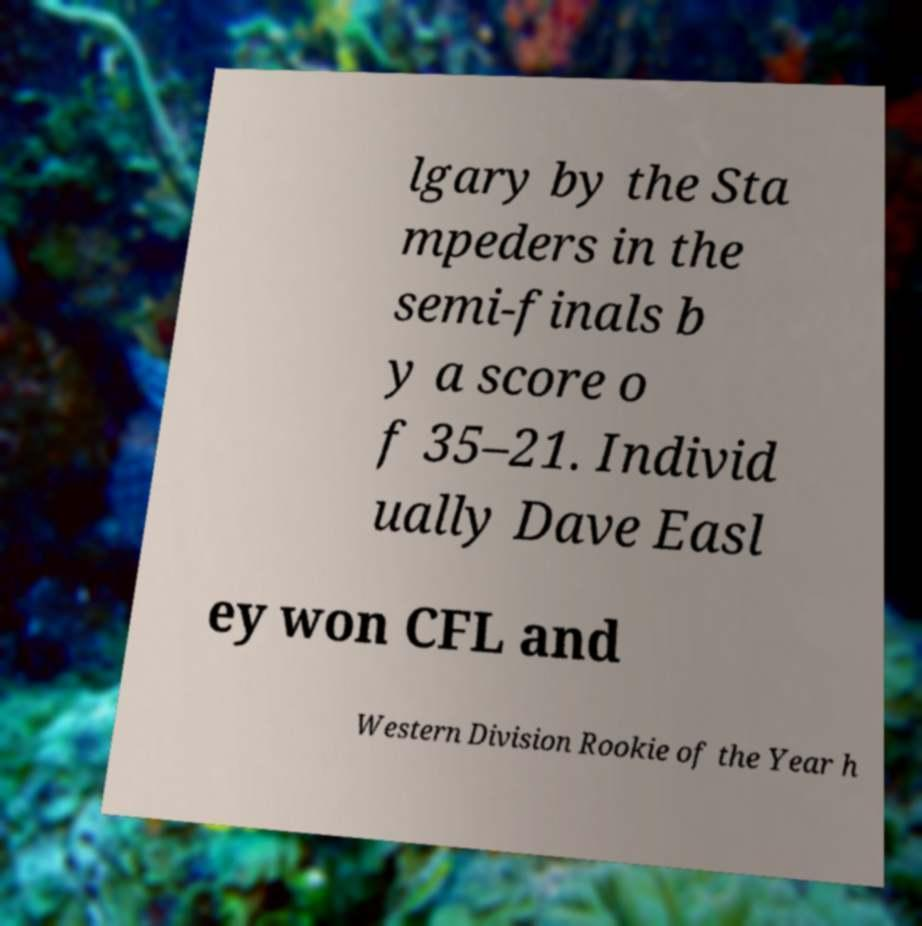Can you read and provide the text displayed in the image?This photo seems to have some interesting text. Can you extract and type it out for me? lgary by the Sta mpeders in the semi-finals b y a score o f 35–21. Individ ually Dave Easl ey won CFL and Western Division Rookie of the Year h 